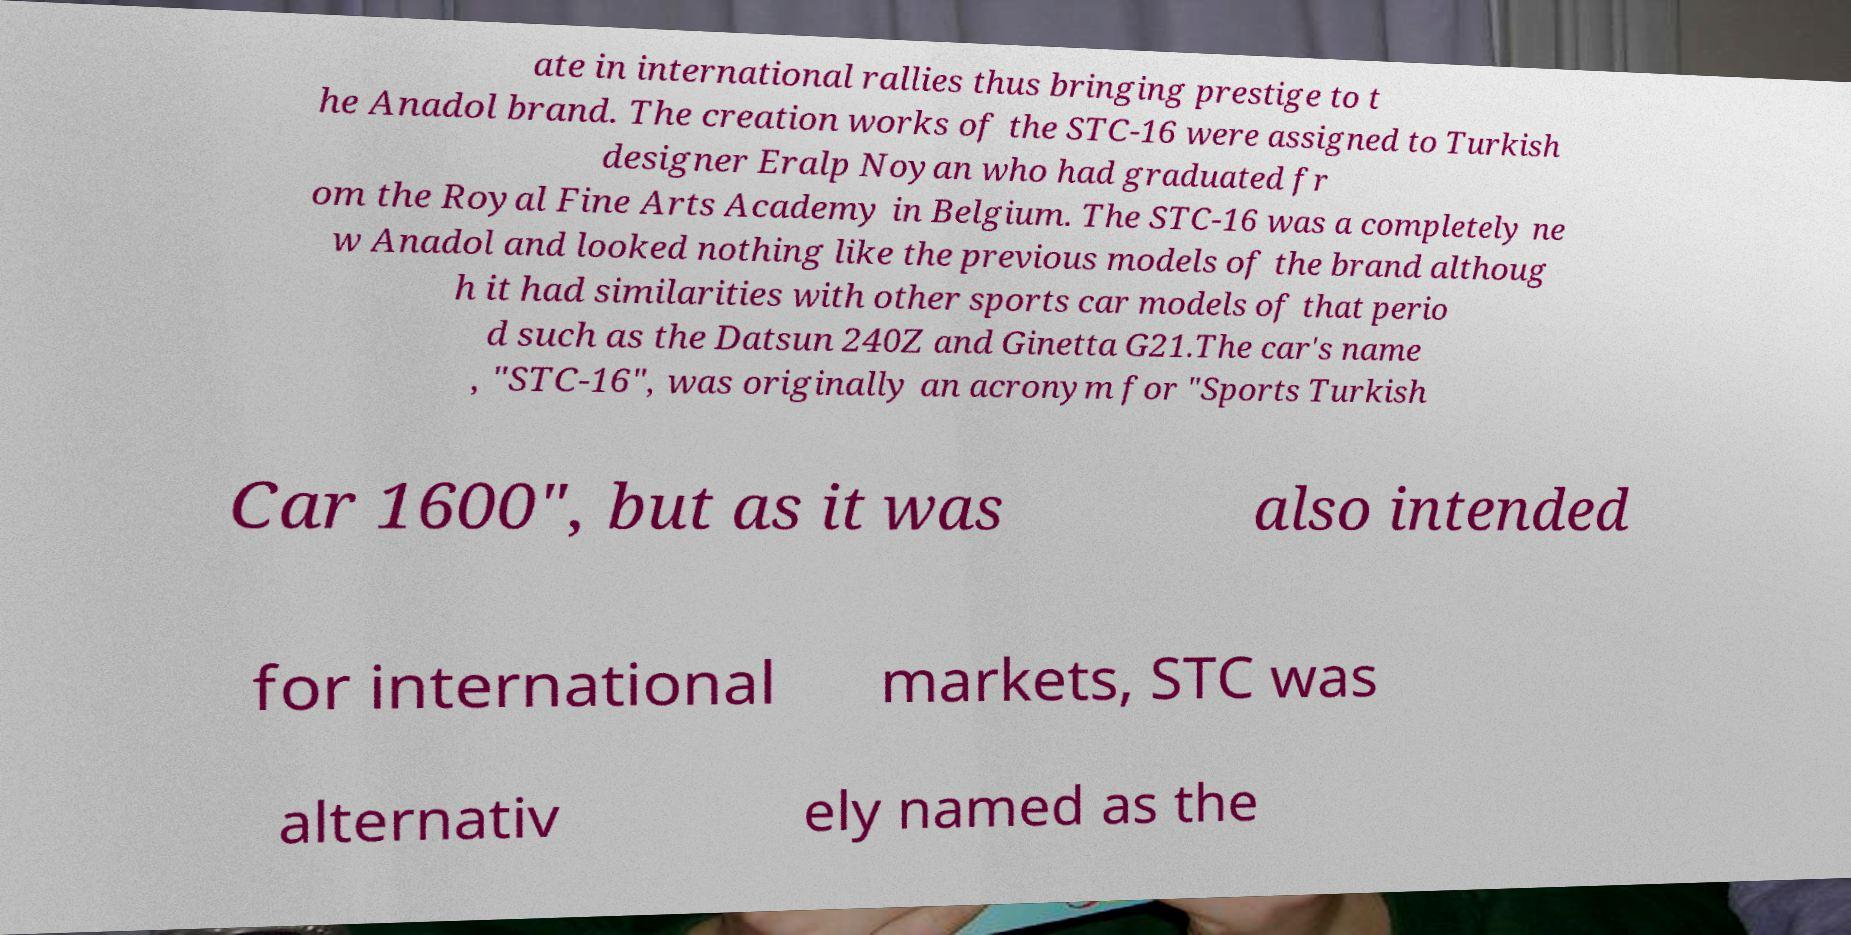For documentation purposes, I need the text within this image transcribed. Could you provide that? ate in international rallies thus bringing prestige to t he Anadol brand. The creation works of the STC-16 were assigned to Turkish designer Eralp Noyan who had graduated fr om the Royal Fine Arts Academy in Belgium. The STC-16 was a completely ne w Anadol and looked nothing like the previous models of the brand althoug h it had similarities with other sports car models of that perio d such as the Datsun 240Z and Ginetta G21.The car's name , "STC-16", was originally an acronym for "Sports Turkish Car 1600", but as it was also intended for international markets, STC was alternativ ely named as the 